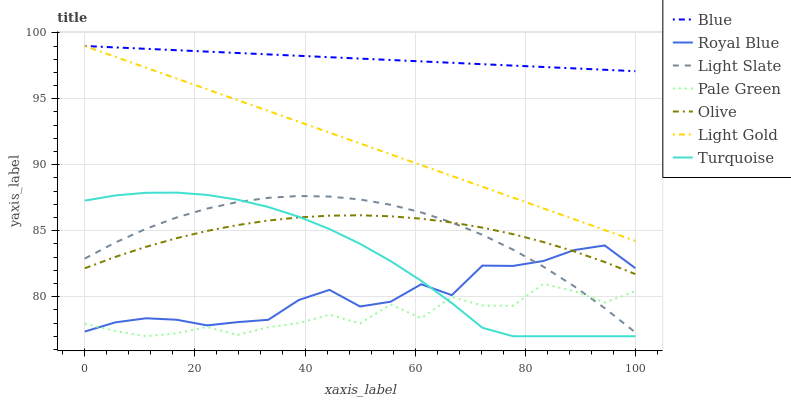Does Pale Green have the minimum area under the curve?
Answer yes or no. Yes. Does Blue have the maximum area under the curve?
Answer yes or no. Yes. Does Turquoise have the minimum area under the curve?
Answer yes or no. No. Does Turquoise have the maximum area under the curve?
Answer yes or no. No. Is Blue the smoothest?
Answer yes or no. Yes. Is Pale Green the roughest?
Answer yes or no. Yes. Is Turquoise the smoothest?
Answer yes or no. No. Is Turquoise the roughest?
Answer yes or no. No. Does Turquoise have the lowest value?
Answer yes or no. Yes. Does Light Slate have the lowest value?
Answer yes or no. No. Does Light Gold have the highest value?
Answer yes or no. Yes. Does Turquoise have the highest value?
Answer yes or no. No. Is Pale Green less than Blue?
Answer yes or no. Yes. Is Blue greater than Light Slate?
Answer yes or no. Yes. Does Royal Blue intersect Olive?
Answer yes or no. Yes. Is Royal Blue less than Olive?
Answer yes or no. No. Is Royal Blue greater than Olive?
Answer yes or no. No. Does Pale Green intersect Blue?
Answer yes or no. No. 